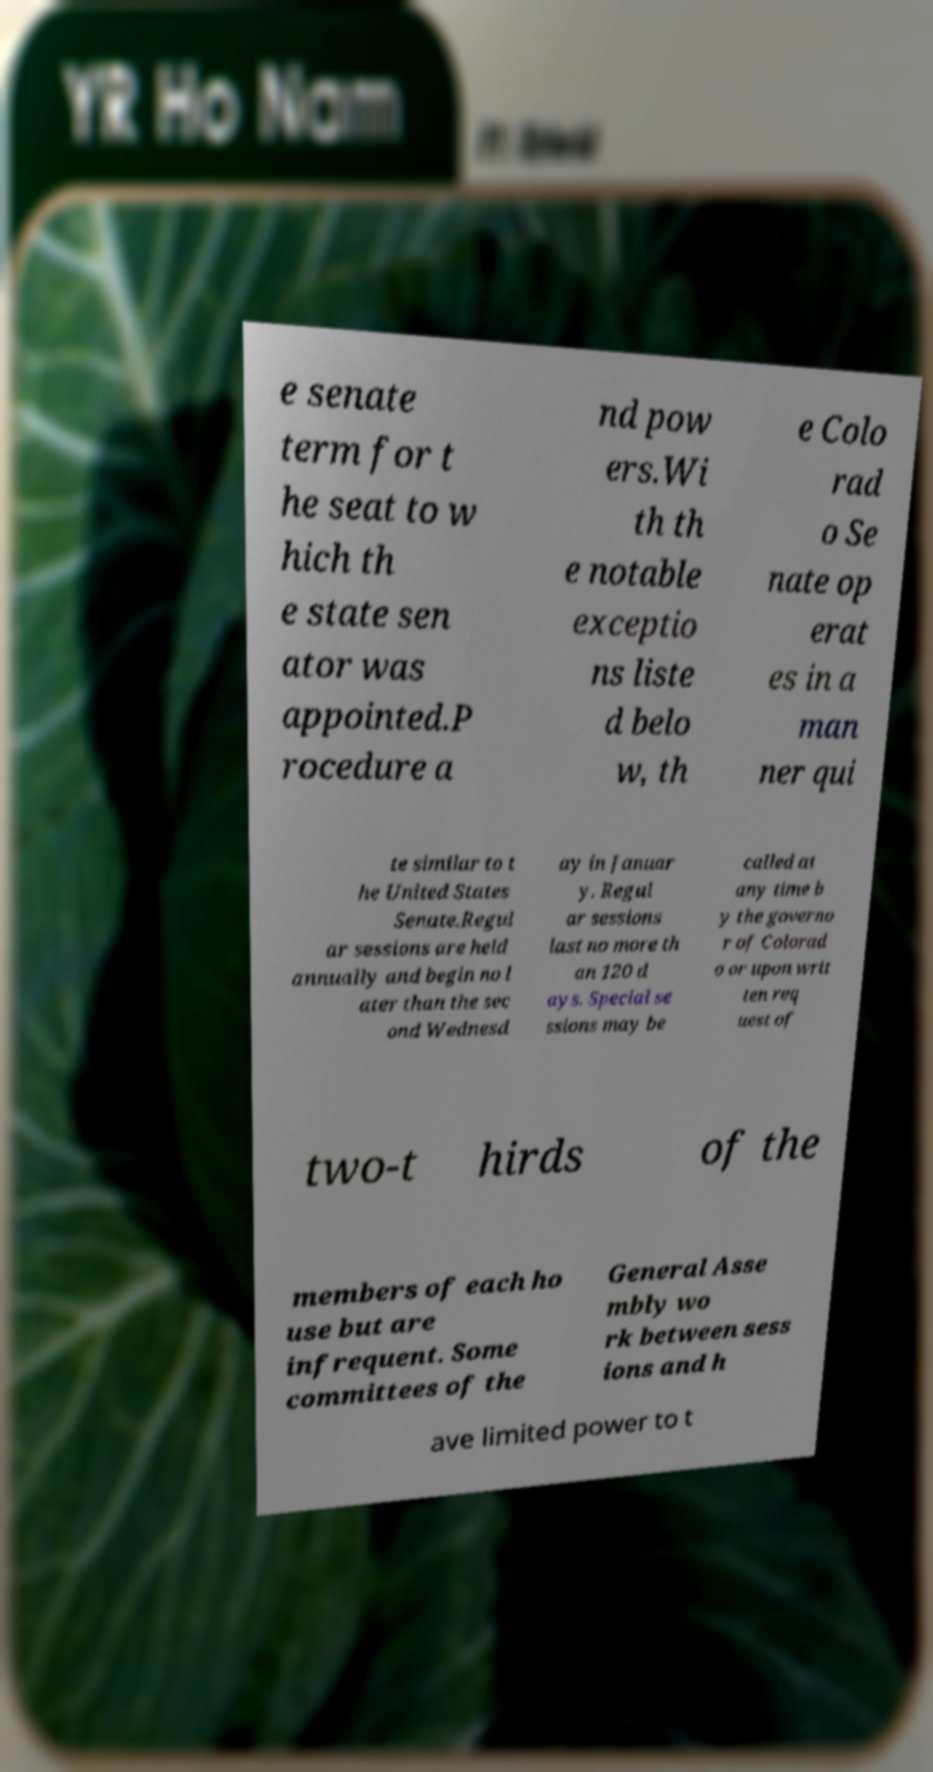Could you extract and type out the text from this image? e senate term for t he seat to w hich th e state sen ator was appointed.P rocedure a nd pow ers.Wi th th e notable exceptio ns liste d belo w, th e Colo rad o Se nate op erat es in a man ner qui te similar to t he United States Senate.Regul ar sessions are held annually and begin no l ater than the sec ond Wednesd ay in Januar y. Regul ar sessions last no more th an 120 d ays. Special se ssions may be called at any time b y the governo r of Colorad o or upon writ ten req uest of two-t hirds of the members of each ho use but are infrequent. Some committees of the General Asse mbly wo rk between sess ions and h ave limited power to t 